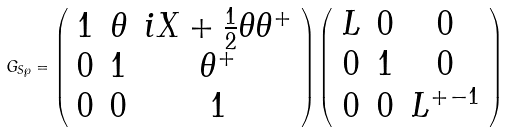<formula> <loc_0><loc_0><loc_500><loc_500>G _ { S \wp } = \left ( \begin{array} { c c c } 1 & \theta & i X + \frac { 1 } { 2 } \theta \theta ^ { + } \\ 0 & 1 & \theta ^ { + } \\ 0 & 0 & 1 \end{array} \right ) \left ( \begin{array} { c c c } L & 0 & 0 \\ 0 & 1 & 0 \\ 0 & 0 & L ^ { + - 1 } \end{array} \right )</formula> 